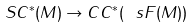Convert formula to latex. <formula><loc_0><loc_0><loc_500><loc_500>S C ^ { * } ( M ) \to C C ^ { * } ( \ s F ( M ) )</formula> 